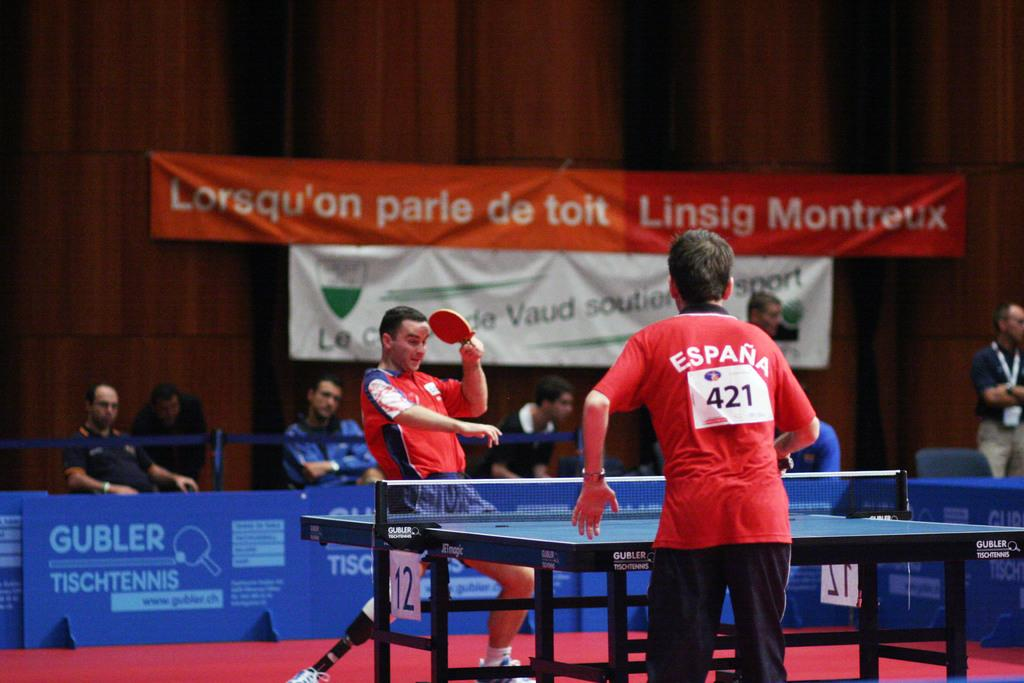<image>
Offer a succinct explanation of the picture presented. Number 421 plays ping pong with an opponent on table 12. 